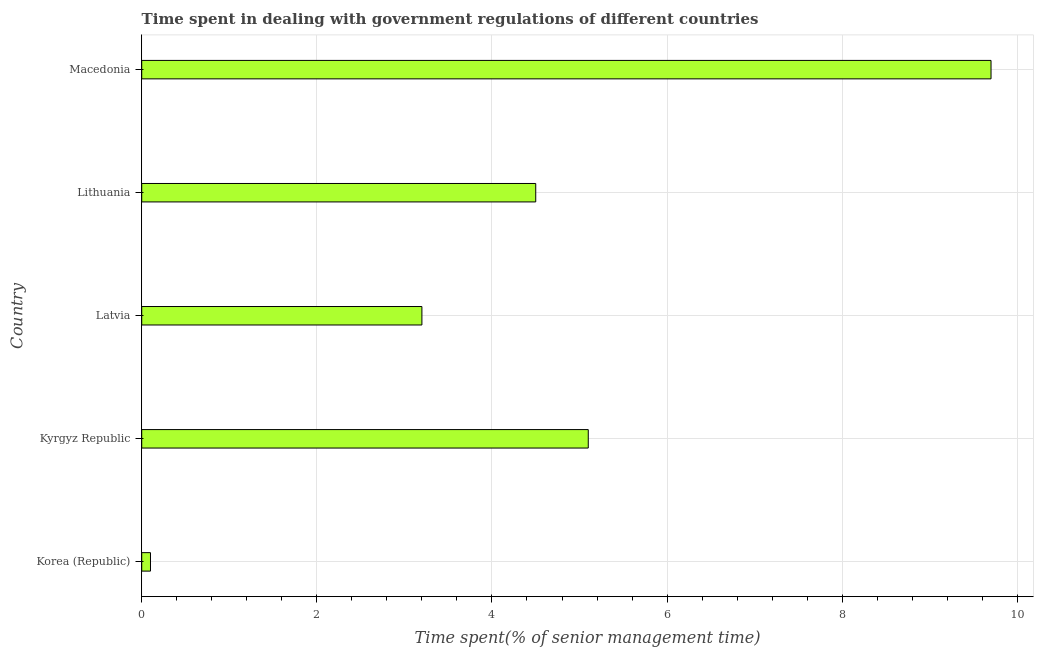Does the graph contain grids?
Make the answer very short. Yes. What is the title of the graph?
Keep it short and to the point. Time spent in dealing with government regulations of different countries. What is the label or title of the X-axis?
Your answer should be very brief. Time spent(% of senior management time). What is the label or title of the Y-axis?
Provide a short and direct response. Country. Across all countries, what is the maximum time spent in dealing with government regulations?
Provide a short and direct response. 9.7. Across all countries, what is the minimum time spent in dealing with government regulations?
Ensure brevity in your answer.  0.1. In which country was the time spent in dealing with government regulations maximum?
Provide a succinct answer. Macedonia. What is the sum of the time spent in dealing with government regulations?
Keep it short and to the point. 22.6. What is the average time spent in dealing with government regulations per country?
Keep it short and to the point. 4.52. What is the median time spent in dealing with government regulations?
Provide a short and direct response. 4.5. What is the ratio of the time spent in dealing with government regulations in Lithuania to that in Macedonia?
Offer a very short reply. 0.46. Are all the bars in the graph horizontal?
Keep it short and to the point. Yes. What is the Time spent(% of senior management time) of Korea (Republic)?
Your answer should be very brief. 0.1. What is the Time spent(% of senior management time) of Kyrgyz Republic?
Ensure brevity in your answer.  5.1. What is the Time spent(% of senior management time) in Latvia?
Your answer should be very brief. 3.2. What is the Time spent(% of senior management time) of Lithuania?
Ensure brevity in your answer.  4.5. What is the Time spent(% of senior management time) in Macedonia?
Give a very brief answer. 9.7. What is the difference between the Time spent(% of senior management time) in Korea (Republic) and Kyrgyz Republic?
Give a very brief answer. -5. What is the difference between the Time spent(% of senior management time) in Korea (Republic) and Lithuania?
Ensure brevity in your answer.  -4.4. What is the difference between the Time spent(% of senior management time) in Kyrgyz Republic and Latvia?
Keep it short and to the point. 1.9. What is the difference between the Time spent(% of senior management time) in Kyrgyz Republic and Macedonia?
Your answer should be compact. -4.6. What is the difference between the Time spent(% of senior management time) in Lithuania and Macedonia?
Provide a succinct answer. -5.2. What is the ratio of the Time spent(% of senior management time) in Korea (Republic) to that in Latvia?
Make the answer very short. 0.03. What is the ratio of the Time spent(% of senior management time) in Korea (Republic) to that in Lithuania?
Keep it short and to the point. 0.02. What is the ratio of the Time spent(% of senior management time) in Korea (Republic) to that in Macedonia?
Give a very brief answer. 0.01. What is the ratio of the Time spent(% of senior management time) in Kyrgyz Republic to that in Latvia?
Your response must be concise. 1.59. What is the ratio of the Time spent(% of senior management time) in Kyrgyz Republic to that in Lithuania?
Make the answer very short. 1.13. What is the ratio of the Time spent(% of senior management time) in Kyrgyz Republic to that in Macedonia?
Ensure brevity in your answer.  0.53. What is the ratio of the Time spent(% of senior management time) in Latvia to that in Lithuania?
Offer a terse response. 0.71. What is the ratio of the Time spent(% of senior management time) in Latvia to that in Macedonia?
Give a very brief answer. 0.33. What is the ratio of the Time spent(% of senior management time) in Lithuania to that in Macedonia?
Your answer should be very brief. 0.46. 